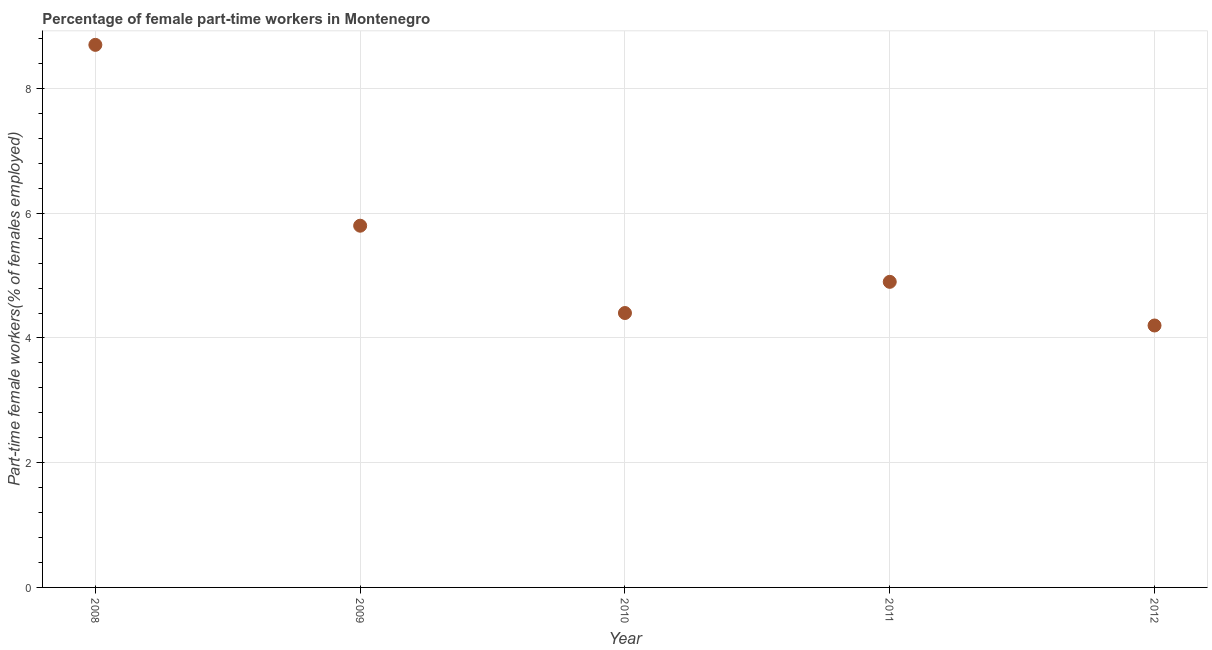What is the percentage of part-time female workers in 2008?
Offer a very short reply. 8.7. Across all years, what is the maximum percentage of part-time female workers?
Keep it short and to the point. 8.7. Across all years, what is the minimum percentage of part-time female workers?
Provide a succinct answer. 4.2. In which year was the percentage of part-time female workers maximum?
Your response must be concise. 2008. In which year was the percentage of part-time female workers minimum?
Give a very brief answer. 2012. What is the sum of the percentage of part-time female workers?
Your answer should be compact. 28. What is the difference between the percentage of part-time female workers in 2011 and 2012?
Offer a terse response. 0.7. What is the average percentage of part-time female workers per year?
Keep it short and to the point. 5.6. What is the median percentage of part-time female workers?
Provide a succinct answer. 4.9. In how many years, is the percentage of part-time female workers greater than 4 %?
Provide a succinct answer. 5. What is the ratio of the percentage of part-time female workers in 2010 to that in 2012?
Ensure brevity in your answer.  1.05. Is the percentage of part-time female workers in 2008 less than that in 2009?
Provide a short and direct response. No. What is the difference between the highest and the second highest percentage of part-time female workers?
Your answer should be compact. 2.9. What is the difference between the highest and the lowest percentage of part-time female workers?
Make the answer very short. 4.5. In how many years, is the percentage of part-time female workers greater than the average percentage of part-time female workers taken over all years?
Provide a short and direct response. 2. Does the percentage of part-time female workers monotonically increase over the years?
Your response must be concise. No. What is the difference between two consecutive major ticks on the Y-axis?
Give a very brief answer. 2. Are the values on the major ticks of Y-axis written in scientific E-notation?
Give a very brief answer. No. What is the title of the graph?
Offer a terse response. Percentage of female part-time workers in Montenegro. What is the label or title of the Y-axis?
Your response must be concise. Part-time female workers(% of females employed). What is the Part-time female workers(% of females employed) in 2008?
Make the answer very short. 8.7. What is the Part-time female workers(% of females employed) in 2009?
Make the answer very short. 5.8. What is the Part-time female workers(% of females employed) in 2010?
Offer a terse response. 4.4. What is the Part-time female workers(% of females employed) in 2011?
Provide a succinct answer. 4.9. What is the Part-time female workers(% of females employed) in 2012?
Provide a short and direct response. 4.2. What is the difference between the Part-time female workers(% of females employed) in 2008 and 2011?
Make the answer very short. 3.8. What is the difference between the Part-time female workers(% of females employed) in 2008 and 2012?
Offer a very short reply. 4.5. What is the difference between the Part-time female workers(% of females employed) in 2009 and 2010?
Your response must be concise. 1.4. What is the difference between the Part-time female workers(% of females employed) in 2009 and 2012?
Provide a succinct answer. 1.6. What is the difference between the Part-time female workers(% of females employed) in 2010 and 2012?
Ensure brevity in your answer.  0.2. What is the difference between the Part-time female workers(% of females employed) in 2011 and 2012?
Offer a terse response. 0.7. What is the ratio of the Part-time female workers(% of females employed) in 2008 to that in 2009?
Provide a succinct answer. 1.5. What is the ratio of the Part-time female workers(% of females employed) in 2008 to that in 2010?
Ensure brevity in your answer.  1.98. What is the ratio of the Part-time female workers(% of females employed) in 2008 to that in 2011?
Your response must be concise. 1.78. What is the ratio of the Part-time female workers(% of females employed) in 2008 to that in 2012?
Your response must be concise. 2.07. What is the ratio of the Part-time female workers(% of females employed) in 2009 to that in 2010?
Ensure brevity in your answer.  1.32. What is the ratio of the Part-time female workers(% of females employed) in 2009 to that in 2011?
Keep it short and to the point. 1.18. What is the ratio of the Part-time female workers(% of females employed) in 2009 to that in 2012?
Provide a succinct answer. 1.38. What is the ratio of the Part-time female workers(% of females employed) in 2010 to that in 2011?
Your response must be concise. 0.9. What is the ratio of the Part-time female workers(% of females employed) in 2010 to that in 2012?
Provide a short and direct response. 1.05. What is the ratio of the Part-time female workers(% of females employed) in 2011 to that in 2012?
Give a very brief answer. 1.17. 